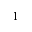<formula> <loc_0><loc_0><loc_500><loc_500>1</formula> 